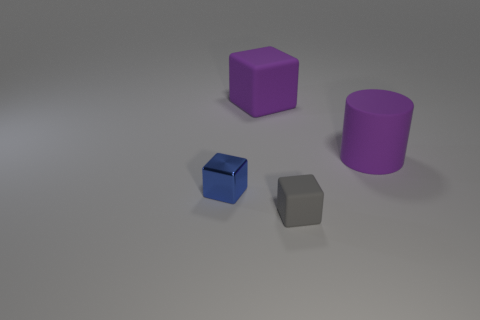Are there any other things that have the same material as the small blue thing?
Make the answer very short. No. Is the large cylinder the same color as the tiny shiny cube?
Provide a succinct answer. No. What is the material of the cube that is in front of the big purple cube and on the right side of the small blue shiny block?
Your answer should be very brief. Rubber. The blue thing is what size?
Provide a short and direct response. Small. What number of purple cylinders are in front of the big purple rubber object that is left of the small object that is in front of the small blue shiny thing?
Your answer should be very brief. 1. What is the shape of the large purple object that is on the right side of the big purple matte thing that is behind the big purple cylinder?
Give a very brief answer. Cylinder. What size is the purple thing that is the same shape as the blue shiny thing?
Provide a short and direct response. Large. Is there anything else that has the same size as the purple matte block?
Make the answer very short. Yes. There is a tiny cube that is to the right of the purple cube; what is its color?
Keep it short and to the point. Gray. There is a small block that is on the right side of the matte cube behind the matte object to the right of the small gray rubber object; what is its material?
Provide a short and direct response. Rubber. 